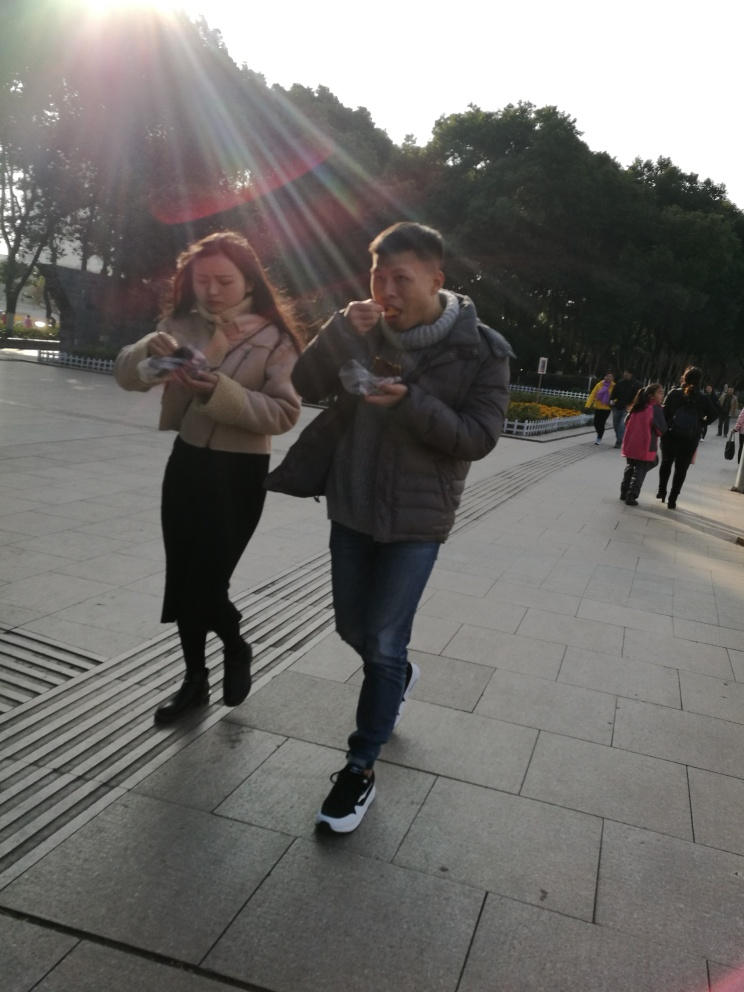What are the people in the photo doing? There are two individuals walking and they both appear to be eating something, possibly snacks or small meals on the go. 